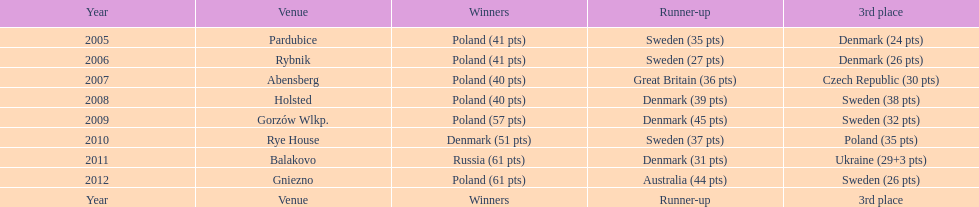In 2009, how many points were earned in total? 134. Give me the full table as a dictionary. {'header': ['Year', 'Venue', 'Winners', 'Runner-up', '3rd place'], 'rows': [['2005', 'Pardubice', 'Poland (41 pts)', 'Sweden (35 pts)', 'Denmark (24 pts)'], ['2006', 'Rybnik', 'Poland (41 pts)', 'Sweden (27 pts)', 'Denmark (26 pts)'], ['2007', 'Abensberg', 'Poland (40 pts)', 'Great Britain (36 pts)', 'Czech Republic (30 pts)'], ['2008', 'Holsted', 'Poland (40 pts)', 'Denmark (39 pts)', 'Sweden (38 pts)'], ['2009', 'Gorzów Wlkp.', 'Poland (57 pts)', 'Denmark (45 pts)', 'Sweden (32 pts)'], ['2010', 'Rye House', 'Denmark (51 pts)', 'Sweden (37 pts)', 'Poland (35 pts)'], ['2011', 'Balakovo', 'Russia (61 pts)', 'Denmark (31 pts)', 'Ukraine (29+3 pts)'], ['2012', 'Gniezno', 'Poland (61 pts)', 'Australia (44 pts)', 'Sweden (26 pts)'], ['Year', 'Venue', 'Winners', 'Runner-up', '3rd place']]} 